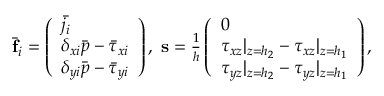<formula> <loc_0><loc_0><loc_500><loc_500>\begin{array} { r } { \bar { f } _ { i } = \left ( \begin{array} { l } { \bar { j _ { i } } } \\ { \delta _ { x i } \bar { p } - \bar { \tau } _ { x i } } \\ { \delta _ { y i } \bar { p } - \bar { \tau } _ { y i } } \end{array} \right ) , \, s = \frac { 1 } { h } \left ( \begin{array} { l } { 0 } \\ { \tau _ { x z } | _ { z = h _ { 2 } } - \tau _ { x z } | _ { z = h _ { 1 } } } \\ { \tau _ { y z } | _ { z = h _ { 2 } } - \tau _ { y z } | _ { z = h _ { 1 } } } \end{array} \right ) , } \end{array}</formula> 